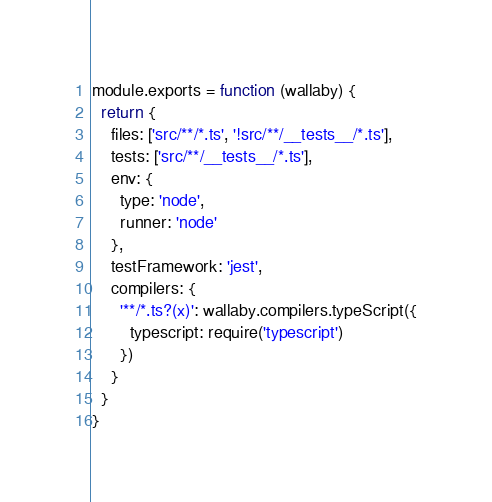Convert code to text. <code><loc_0><loc_0><loc_500><loc_500><_JavaScript_>module.exports = function (wallaby) {
  return {
    files: ['src/**/*.ts', '!src/**/__tests__/*.ts'],
    tests: ['src/**/__tests__/*.ts'],
    env: {
      type: 'node',
      runner: 'node'
    },
    testFramework: 'jest',
    compilers: {
      '**/*.ts?(x)': wallaby.compilers.typeScript({
        typescript: require('typescript')
      })
    }
  }
}
</code> 